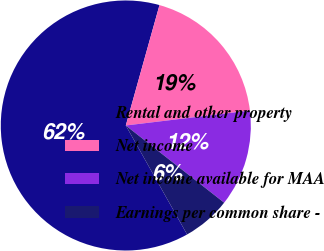Convert chart. <chart><loc_0><loc_0><loc_500><loc_500><pie_chart><fcel>Rental and other property<fcel>Net income<fcel>Net income available for MAA<fcel>Earnings per common share -<nl><fcel>62.5%<fcel>18.75%<fcel>12.5%<fcel>6.25%<nl></chart> 